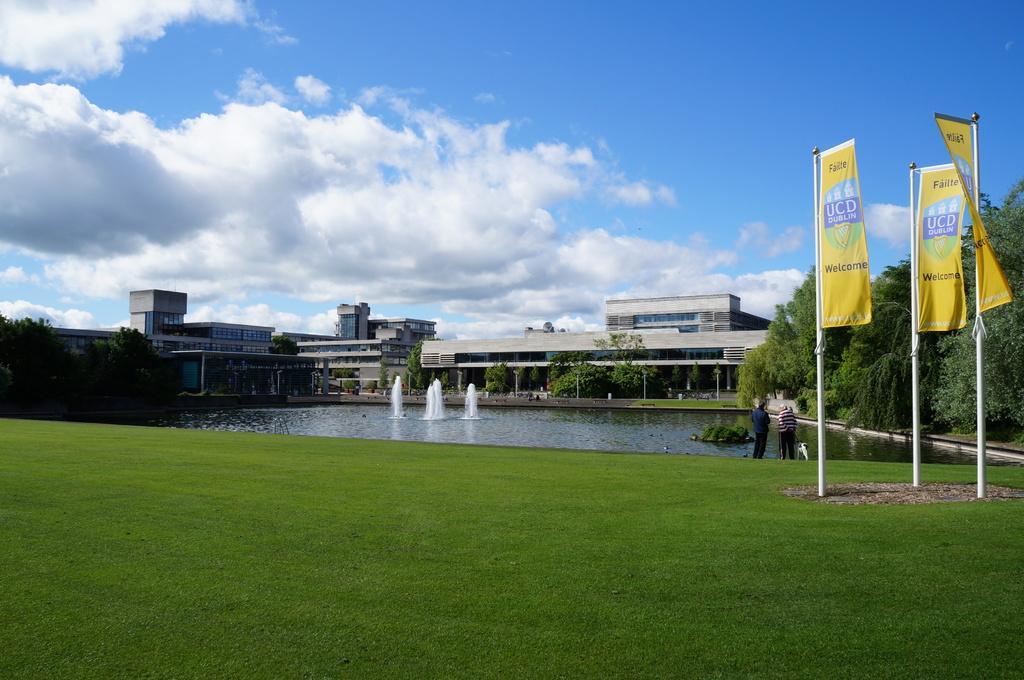Could you give a brief overview of what you see in this image? In this image, we can see buildings, trees, people, plants, water fountain, grass and poles. On the right side of the image, we can see banners. Background we can see the cloudy sky. 